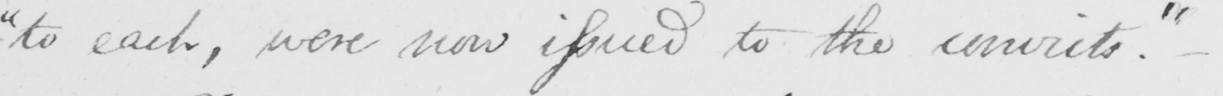Can you read and transcribe this handwriting? " to each , were now issued to the convicts . "  _ 